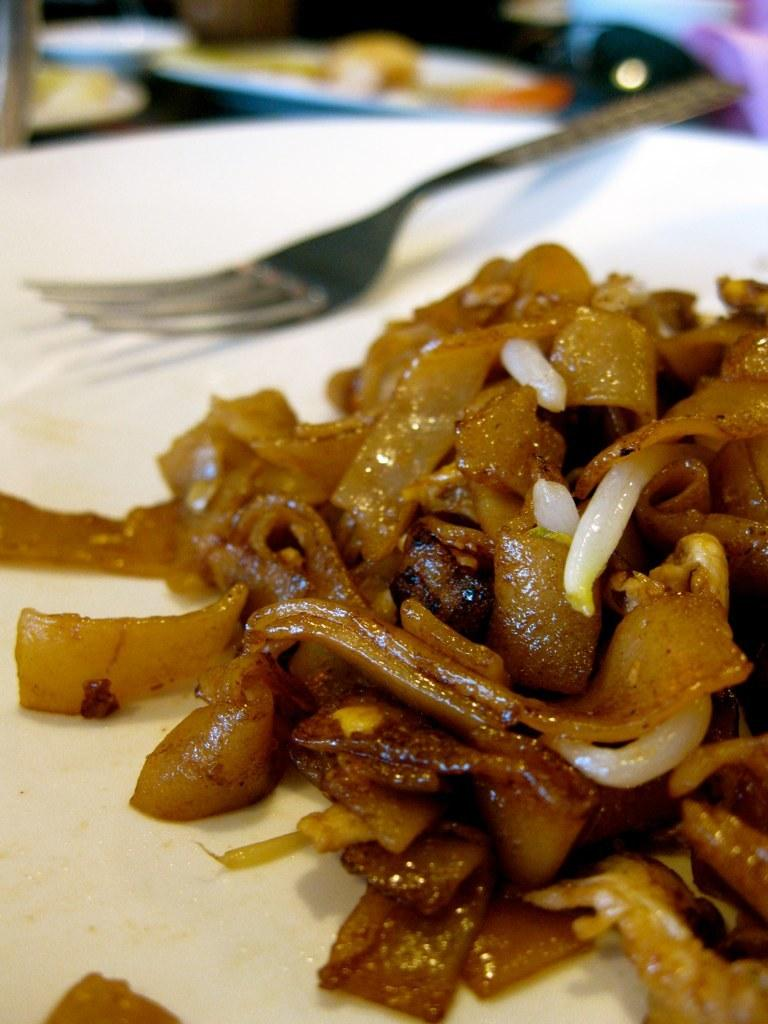What can be seen on the plates in the image? There are food items on plates in the image. Can you describe any utensils visible in the image? Yes, there is a fork on a plate in the image. What can be observed about the background of the image? The background of the image is blurred. What type of arch can be seen in the image? There is no arch present in the image. What kind of structure is visible in the image? The image does not show any specific structures; it primarily features food items on plates. 